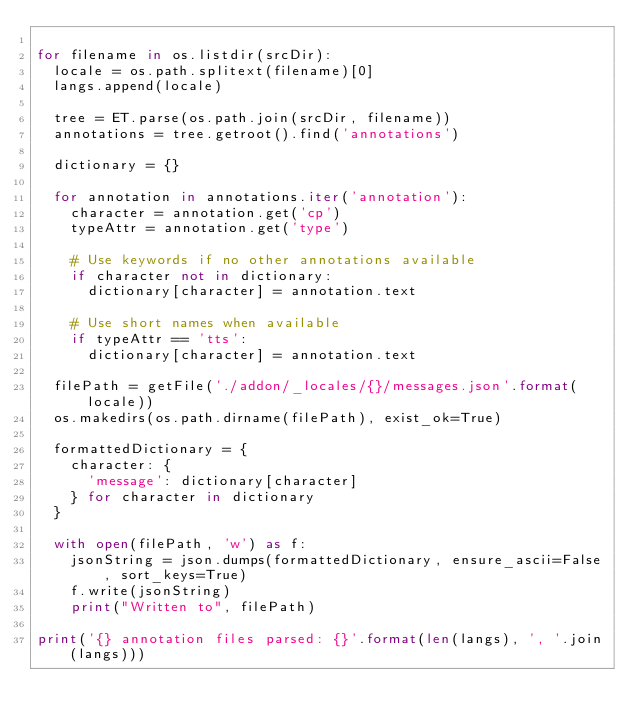<code> <loc_0><loc_0><loc_500><loc_500><_Python_>
for filename in os.listdir(srcDir):
	locale = os.path.splitext(filename)[0]
	langs.append(locale)

	tree = ET.parse(os.path.join(srcDir, filename))
	annotations = tree.getroot().find('annotations')

	dictionary = {}

	for annotation in annotations.iter('annotation'):
		character = annotation.get('cp')
		typeAttr = annotation.get('type')

		# Use keywords if no other annotations available
		if character not in dictionary:
			dictionary[character] = annotation.text

		# Use short names when available
		if typeAttr == 'tts':
			dictionary[character] = annotation.text

	filePath = getFile('./addon/_locales/{}/messages.json'.format(locale))
	os.makedirs(os.path.dirname(filePath), exist_ok=True)

	formattedDictionary = {
		character: {
			'message': dictionary[character]
		} for character in dictionary
	}

	with open(filePath, 'w') as f:
		jsonString = json.dumps(formattedDictionary, ensure_ascii=False, sort_keys=True)
		f.write(jsonString)
		print("Written to", filePath)

print('{} annotation files parsed: {}'.format(len(langs), ', '.join(langs)))</code> 